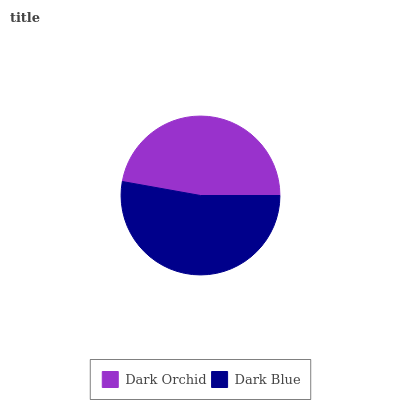Is Dark Orchid the minimum?
Answer yes or no. Yes. Is Dark Blue the maximum?
Answer yes or no. Yes. Is Dark Blue the minimum?
Answer yes or no. No. Is Dark Blue greater than Dark Orchid?
Answer yes or no. Yes. Is Dark Orchid less than Dark Blue?
Answer yes or no. Yes. Is Dark Orchid greater than Dark Blue?
Answer yes or no. No. Is Dark Blue less than Dark Orchid?
Answer yes or no. No. Is Dark Blue the high median?
Answer yes or no. Yes. Is Dark Orchid the low median?
Answer yes or no. Yes. Is Dark Orchid the high median?
Answer yes or no. No. Is Dark Blue the low median?
Answer yes or no. No. 